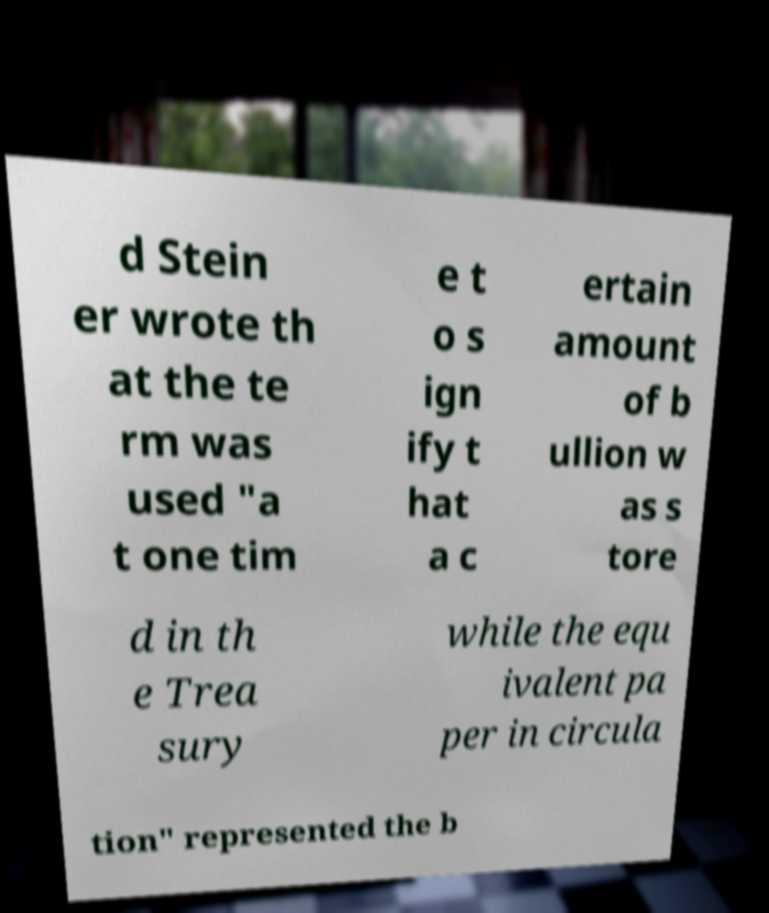Can you accurately transcribe the text from the provided image for me? d Stein er wrote th at the te rm was used "a t one tim e t o s ign ify t hat a c ertain amount of b ullion w as s tore d in th e Trea sury while the equ ivalent pa per in circula tion" represented the b 